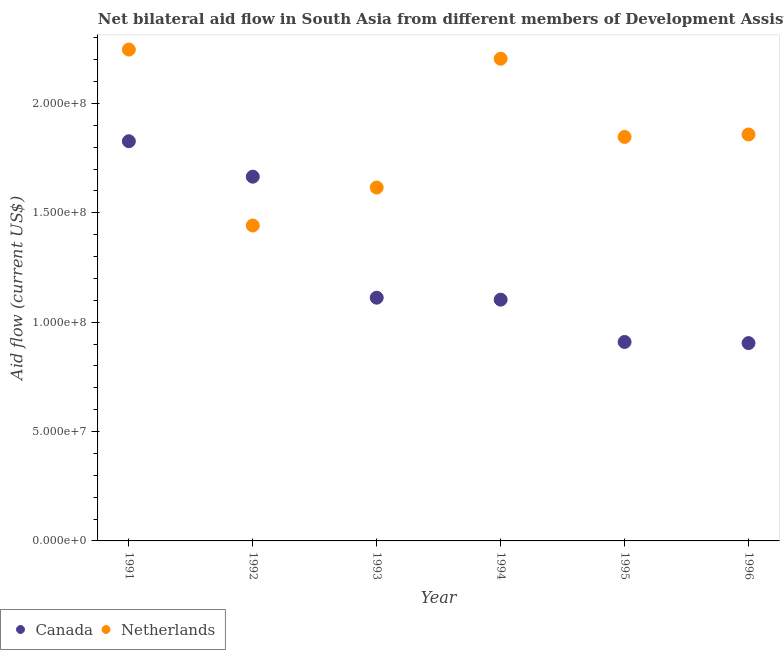How many different coloured dotlines are there?
Ensure brevity in your answer.  2. What is the amount of aid given by canada in 1991?
Keep it short and to the point. 1.83e+08. Across all years, what is the maximum amount of aid given by netherlands?
Ensure brevity in your answer.  2.25e+08. Across all years, what is the minimum amount of aid given by canada?
Keep it short and to the point. 9.04e+07. What is the total amount of aid given by netherlands in the graph?
Provide a short and direct response. 1.12e+09. What is the difference between the amount of aid given by netherlands in 1992 and that in 1994?
Offer a very short reply. -7.62e+07. What is the difference between the amount of aid given by netherlands in 1994 and the amount of aid given by canada in 1992?
Offer a terse response. 5.39e+07. What is the average amount of aid given by netherlands per year?
Provide a short and direct response. 1.87e+08. In the year 1993, what is the difference between the amount of aid given by canada and amount of aid given by netherlands?
Provide a short and direct response. -5.04e+07. What is the ratio of the amount of aid given by netherlands in 1991 to that in 1996?
Give a very brief answer. 1.21. What is the difference between the highest and the second highest amount of aid given by netherlands?
Your answer should be compact. 4.19e+06. What is the difference between the highest and the lowest amount of aid given by netherlands?
Keep it short and to the point. 8.04e+07. In how many years, is the amount of aid given by netherlands greater than the average amount of aid given by netherlands taken over all years?
Your answer should be compact. 2. Does the amount of aid given by canada monotonically increase over the years?
Ensure brevity in your answer.  No. Is the amount of aid given by netherlands strictly greater than the amount of aid given by canada over the years?
Keep it short and to the point. No. How many years are there in the graph?
Keep it short and to the point. 6. Does the graph contain any zero values?
Your answer should be very brief. No. Does the graph contain grids?
Provide a short and direct response. No. Where does the legend appear in the graph?
Make the answer very short. Bottom left. How many legend labels are there?
Make the answer very short. 2. How are the legend labels stacked?
Your answer should be compact. Horizontal. What is the title of the graph?
Give a very brief answer. Net bilateral aid flow in South Asia from different members of Development Assistance Committee. What is the label or title of the X-axis?
Your answer should be compact. Year. What is the Aid flow (current US$) in Canada in 1991?
Keep it short and to the point. 1.83e+08. What is the Aid flow (current US$) in Netherlands in 1991?
Offer a terse response. 2.25e+08. What is the Aid flow (current US$) in Canada in 1992?
Provide a succinct answer. 1.66e+08. What is the Aid flow (current US$) of Netherlands in 1992?
Provide a short and direct response. 1.44e+08. What is the Aid flow (current US$) in Canada in 1993?
Make the answer very short. 1.11e+08. What is the Aid flow (current US$) in Netherlands in 1993?
Your answer should be compact. 1.62e+08. What is the Aid flow (current US$) of Canada in 1994?
Your answer should be compact. 1.10e+08. What is the Aid flow (current US$) in Netherlands in 1994?
Ensure brevity in your answer.  2.20e+08. What is the Aid flow (current US$) in Canada in 1995?
Your answer should be very brief. 9.09e+07. What is the Aid flow (current US$) of Netherlands in 1995?
Offer a terse response. 1.85e+08. What is the Aid flow (current US$) in Canada in 1996?
Offer a terse response. 9.04e+07. What is the Aid flow (current US$) in Netherlands in 1996?
Keep it short and to the point. 1.86e+08. Across all years, what is the maximum Aid flow (current US$) of Canada?
Give a very brief answer. 1.83e+08. Across all years, what is the maximum Aid flow (current US$) in Netherlands?
Ensure brevity in your answer.  2.25e+08. Across all years, what is the minimum Aid flow (current US$) of Canada?
Ensure brevity in your answer.  9.04e+07. Across all years, what is the minimum Aid flow (current US$) of Netherlands?
Your answer should be compact. 1.44e+08. What is the total Aid flow (current US$) of Canada in the graph?
Offer a very short reply. 7.52e+08. What is the total Aid flow (current US$) of Netherlands in the graph?
Provide a succinct answer. 1.12e+09. What is the difference between the Aid flow (current US$) of Canada in 1991 and that in 1992?
Make the answer very short. 1.62e+07. What is the difference between the Aid flow (current US$) of Netherlands in 1991 and that in 1992?
Your answer should be very brief. 8.04e+07. What is the difference between the Aid flow (current US$) in Canada in 1991 and that in 1993?
Ensure brevity in your answer.  7.15e+07. What is the difference between the Aid flow (current US$) of Netherlands in 1991 and that in 1993?
Your answer should be compact. 6.31e+07. What is the difference between the Aid flow (current US$) of Canada in 1991 and that in 1994?
Give a very brief answer. 7.24e+07. What is the difference between the Aid flow (current US$) in Netherlands in 1991 and that in 1994?
Make the answer very short. 4.19e+06. What is the difference between the Aid flow (current US$) of Canada in 1991 and that in 1995?
Your answer should be compact. 9.18e+07. What is the difference between the Aid flow (current US$) of Netherlands in 1991 and that in 1995?
Your answer should be compact. 4.00e+07. What is the difference between the Aid flow (current US$) of Canada in 1991 and that in 1996?
Your answer should be compact. 9.23e+07. What is the difference between the Aid flow (current US$) of Netherlands in 1991 and that in 1996?
Give a very brief answer. 3.88e+07. What is the difference between the Aid flow (current US$) in Canada in 1992 and that in 1993?
Offer a terse response. 5.53e+07. What is the difference between the Aid flow (current US$) in Netherlands in 1992 and that in 1993?
Offer a terse response. -1.74e+07. What is the difference between the Aid flow (current US$) of Canada in 1992 and that in 1994?
Your response must be concise. 5.62e+07. What is the difference between the Aid flow (current US$) of Netherlands in 1992 and that in 1994?
Keep it short and to the point. -7.62e+07. What is the difference between the Aid flow (current US$) in Canada in 1992 and that in 1995?
Your answer should be compact. 7.56e+07. What is the difference between the Aid flow (current US$) of Netherlands in 1992 and that in 1995?
Provide a short and direct response. -4.05e+07. What is the difference between the Aid flow (current US$) of Canada in 1992 and that in 1996?
Make the answer very short. 7.61e+07. What is the difference between the Aid flow (current US$) of Netherlands in 1992 and that in 1996?
Your answer should be compact. -4.16e+07. What is the difference between the Aid flow (current US$) of Netherlands in 1993 and that in 1994?
Make the answer very short. -5.89e+07. What is the difference between the Aid flow (current US$) of Canada in 1993 and that in 1995?
Offer a very short reply. 2.02e+07. What is the difference between the Aid flow (current US$) of Netherlands in 1993 and that in 1995?
Your answer should be compact. -2.31e+07. What is the difference between the Aid flow (current US$) in Canada in 1993 and that in 1996?
Make the answer very short. 2.08e+07. What is the difference between the Aid flow (current US$) of Netherlands in 1993 and that in 1996?
Your response must be concise. -2.43e+07. What is the difference between the Aid flow (current US$) of Canada in 1994 and that in 1995?
Your answer should be compact. 1.93e+07. What is the difference between the Aid flow (current US$) in Netherlands in 1994 and that in 1995?
Your answer should be very brief. 3.58e+07. What is the difference between the Aid flow (current US$) of Canada in 1994 and that in 1996?
Provide a succinct answer. 1.98e+07. What is the difference between the Aid flow (current US$) of Netherlands in 1994 and that in 1996?
Keep it short and to the point. 3.46e+07. What is the difference between the Aid flow (current US$) of Canada in 1995 and that in 1996?
Ensure brevity in your answer.  5.10e+05. What is the difference between the Aid flow (current US$) of Netherlands in 1995 and that in 1996?
Provide a short and direct response. -1.13e+06. What is the difference between the Aid flow (current US$) of Canada in 1991 and the Aid flow (current US$) of Netherlands in 1992?
Make the answer very short. 3.85e+07. What is the difference between the Aid flow (current US$) in Canada in 1991 and the Aid flow (current US$) in Netherlands in 1993?
Your response must be concise. 2.12e+07. What is the difference between the Aid flow (current US$) of Canada in 1991 and the Aid flow (current US$) of Netherlands in 1994?
Your answer should be compact. -3.77e+07. What is the difference between the Aid flow (current US$) of Canada in 1991 and the Aid flow (current US$) of Netherlands in 1995?
Your answer should be compact. -1.96e+06. What is the difference between the Aid flow (current US$) in Canada in 1991 and the Aid flow (current US$) in Netherlands in 1996?
Keep it short and to the point. -3.09e+06. What is the difference between the Aid flow (current US$) in Canada in 1992 and the Aid flow (current US$) in Netherlands in 1993?
Your response must be concise. 4.97e+06. What is the difference between the Aid flow (current US$) of Canada in 1992 and the Aid flow (current US$) of Netherlands in 1994?
Keep it short and to the point. -5.39e+07. What is the difference between the Aid flow (current US$) of Canada in 1992 and the Aid flow (current US$) of Netherlands in 1995?
Provide a short and direct response. -1.82e+07. What is the difference between the Aid flow (current US$) in Canada in 1992 and the Aid flow (current US$) in Netherlands in 1996?
Your response must be concise. -1.93e+07. What is the difference between the Aid flow (current US$) in Canada in 1993 and the Aid flow (current US$) in Netherlands in 1994?
Make the answer very short. -1.09e+08. What is the difference between the Aid flow (current US$) of Canada in 1993 and the Aid flow (current US$) of Netherlands in 1995?
Provide a succinct answer. -7.35e+07. What is the difference between the Aid flow (current US$) in Canada in 1993 and the Aid flow (current US$) in Netherlands in 1996?
Make the answer very short. -7.46e+07. What is the difference between the Aid flow (current US$) of Canada in 1994 and the Aid flow (current US$) of Netherlands in 1995?
Offer a very short reply. -7.44e+07. What is the difference between the Aid flow (current US$) of Canada in 1994 and the Aid flow (current US$) of Netherlands in 1996?
Offer a very short reply. -7.55e+07. What is the difference between the Aid flow (current US$) in Canada in 1995 and the Aid flow (current US$) in Netherlands in 1996?
Provide a succinct answer. -9.48e+07. What is the average Aid flow (current US$) in Canada per year?
Make the answer very short. 1.25e+08. What is the average Aid flow (current US$) in Netherlands per year?
Give a very brief answer. 1.87e+08. In the year 1991, what is the difference between the Aid flow (current US$) in Canada and Aid flow (current US$) in Netherlands?
Ensure brevity in your answer.  -4.19e+07. In the year 1992, what is the difference between the Aid flow (current US$) of Canada and Aid flow (current US$) of Netherlands?
Make the answer very short. 2.23e+07. In the year 1993, what is the difference between the Aid flow (current US$) of Canada and Aid flow (current US$) of Netherlands?
Provide a succinct answer. -5.04e+07. In the year 1994, what is the difference between the Aid flow (current US$) of Canada and Aid flow (current US$) of Netherlands?
Your response must be concise. -1.10e+08. In the year 1995, what is the difference between the Aid flow (current US$) of Canada and Aid flow (current US$) of Netherlands?
Make the answer very short. -9.37e+07. In the year 1996, what is the difference between the Aid flow (current US$) of Canada and Aid flow (current US$) of Netherlands?
Make the answer very short. -9.54e+07. What is the ratio of the Aid flow (current US$) in Canada in 1991 to that in 1992?
Offer a very short reply. 1.1. What is the ratio of the Aid flow (current US$) of Netherlands in 1991 to that in 1992?
Your answer should be very brief. 1.56. What is the ratio of the Aid flow (current US$) of Canada in 1991 to that in 1993?
Your answer should be compact. 1.64. What is the ratio of the Aid flow (current US$) in Netherlands in 1991 to that in 1993?
Offer a terse response. 1.39. What is the ratio of the Aid flow (current US$) of Canada in 1991 to that in 1994?
Provide a short and direct response. 1.66. What is the ratio of the Aid flow (current US$) of Canada in 1991 to that in 1995?
Provide a short and direct response. 2.01. What is the ratio of the Aid flow (current US$) in Netherlands in 1991 to that in 1995?
Offer a very short reply. 1.22. What is the ratio of the Aid flow (current US$) in Canada in 1991 to that in 1996?
Offer a terse response. 2.02. What is the ratio of the Aid flow (current US$) of Netherlands in 1991 to that in 1996?
Make the answer very short. 1.21. What is the ratio of the Aid flow (current US$) of Canada in 1992 to that in 1993?
Provide a short and direct response. 1.5. What is the ratio of the Aid flow (current US$) in Netherlands in 1992 to that in 1993?
Your answer should be very brief. 0.89. What is the ratio of the Aid flow (current US$) in Canada in 1992 to that in 1994?
Your answer should be compact. 1.51. What is the ratio of the Aid flow (current US$) of Netherlands in 1992 to that in 1994?
Your response must be concise. 0.65. What is the ratio of the Aid flow (current US$) of Canada in 1992 to that in 1995?
Your answer should be compact. 1.83. What is the ratio of the Aid flow (current US$) of Netherlands in 1992 to that in 1995?
Provide a succinct answer. 0.78. What is the ratio of the Aid flow (current US$) in Canada in 1992 to that in 1996?
Give a very brief answer. 1.84. What is the ratio of the Aid flow (current US$) in Netherlands in 1992 to that in 1996?
Ensure brevity in your answer.  0.78. What is the ratio of the Aid flow (current US$) of Canada in 1993 to that in 1994?
Ensure brevity in your answer.  1.01. What is the ratio of the Aid flow (current US$) in Netherlands in 1993 to that in 1994?
Offer a very short reply. 0.73. What is the ratio of the Aid flow (current US$) of Canada in 1993 to that in 1995?
Give a very brief answer. 1.22. What is the ratio of the Aid flow (current US$) in Netherlands in 1993 to that in 1995?
Make the answer very short. 0.87. What is the ratio of the Aid flow (current US$) of Canada in 1993 to that in 1996?
Keep it short and to the point. 1.23. What is the ratio of the Aid flow (current US$) in Netherlands in 1993 to that in 1996?
Give a very brief answer. 0.87. What is the ratio of the Aid flow (current US$) of Canada in 1994 to that in 1995?
Offer a terse response. 1.21. What is the ratio of the Aid flow (current US$) of Netherlands in 1994 to that in 1995?
Give a very brief answer. 1.19. What is the ratio of the Aid flow (current US$) in Canada in 1994 to that in 1996?
Offer a terse response. 1.22. What is the ratio of the Aid flow (current US$) in Netherlands in 1994 to that in 1996?
Your answer should be very brief. 1.19. What is the ratio of the Aid flow (current US$) of Canada in 1995 to that in 1996?
Keep it short and to the point. 1.01. What is the difference between the highest and the second highest Aid flow (current US$) in Canada?
Keep it short and to the point. 1.62e+07. What is the difference between the highest and the second highest Aid flow (current US$) in Netherlands?
Offer a terse response. 4.19e+06. What is the difference between the highest and the lowest Aid flow (current US$) of Canada?
Keep it short and to the point. 9.23e+07. What is the difference between the highest and the lowest Aid flow (current US$) of Netherlands?
Give a very brief answer. 8.04e+07. 